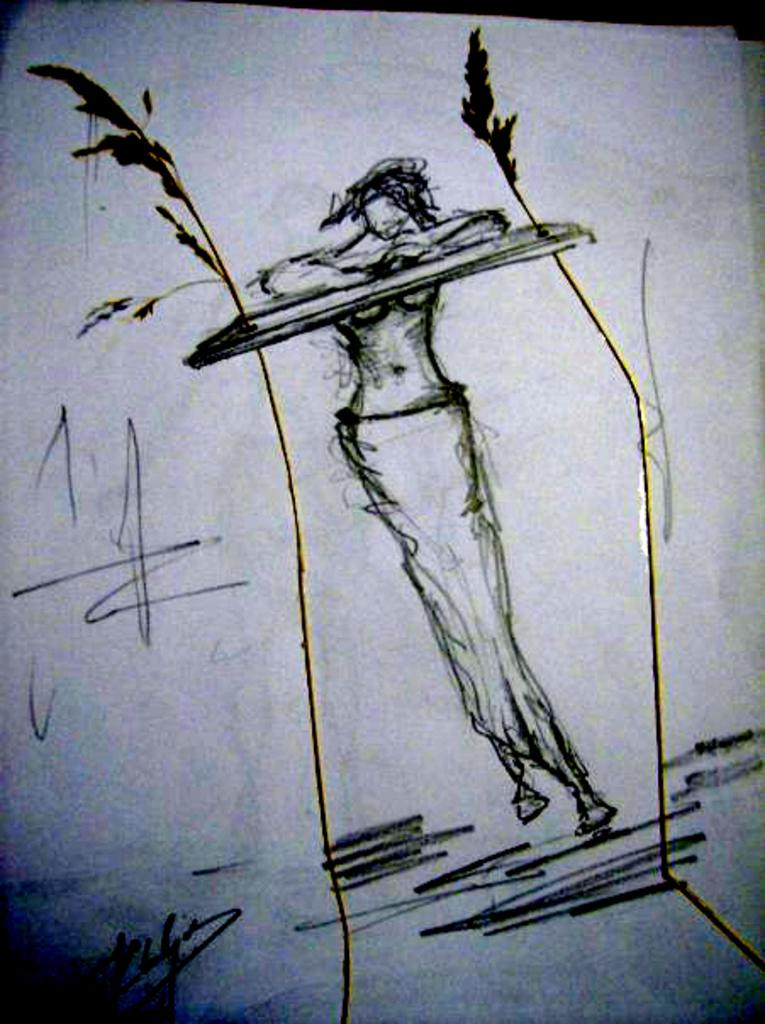What is depicted on the paper in the image? There is a drawing of a person on the paper. Can you describe the drawing in more detail? Unfortunately, the details of the drawing cannot be discerned from the image. What is the primary purpose of the paper in the image? The paper appears to be used for drawing or sketching. What type of dinner is being served in the image? There is no dinner present in the image; it only features a paper with a drawing of a person. Is there a letter being written in the image? There is no letter being written in the image; it only features a paper with a drawing of a person. 